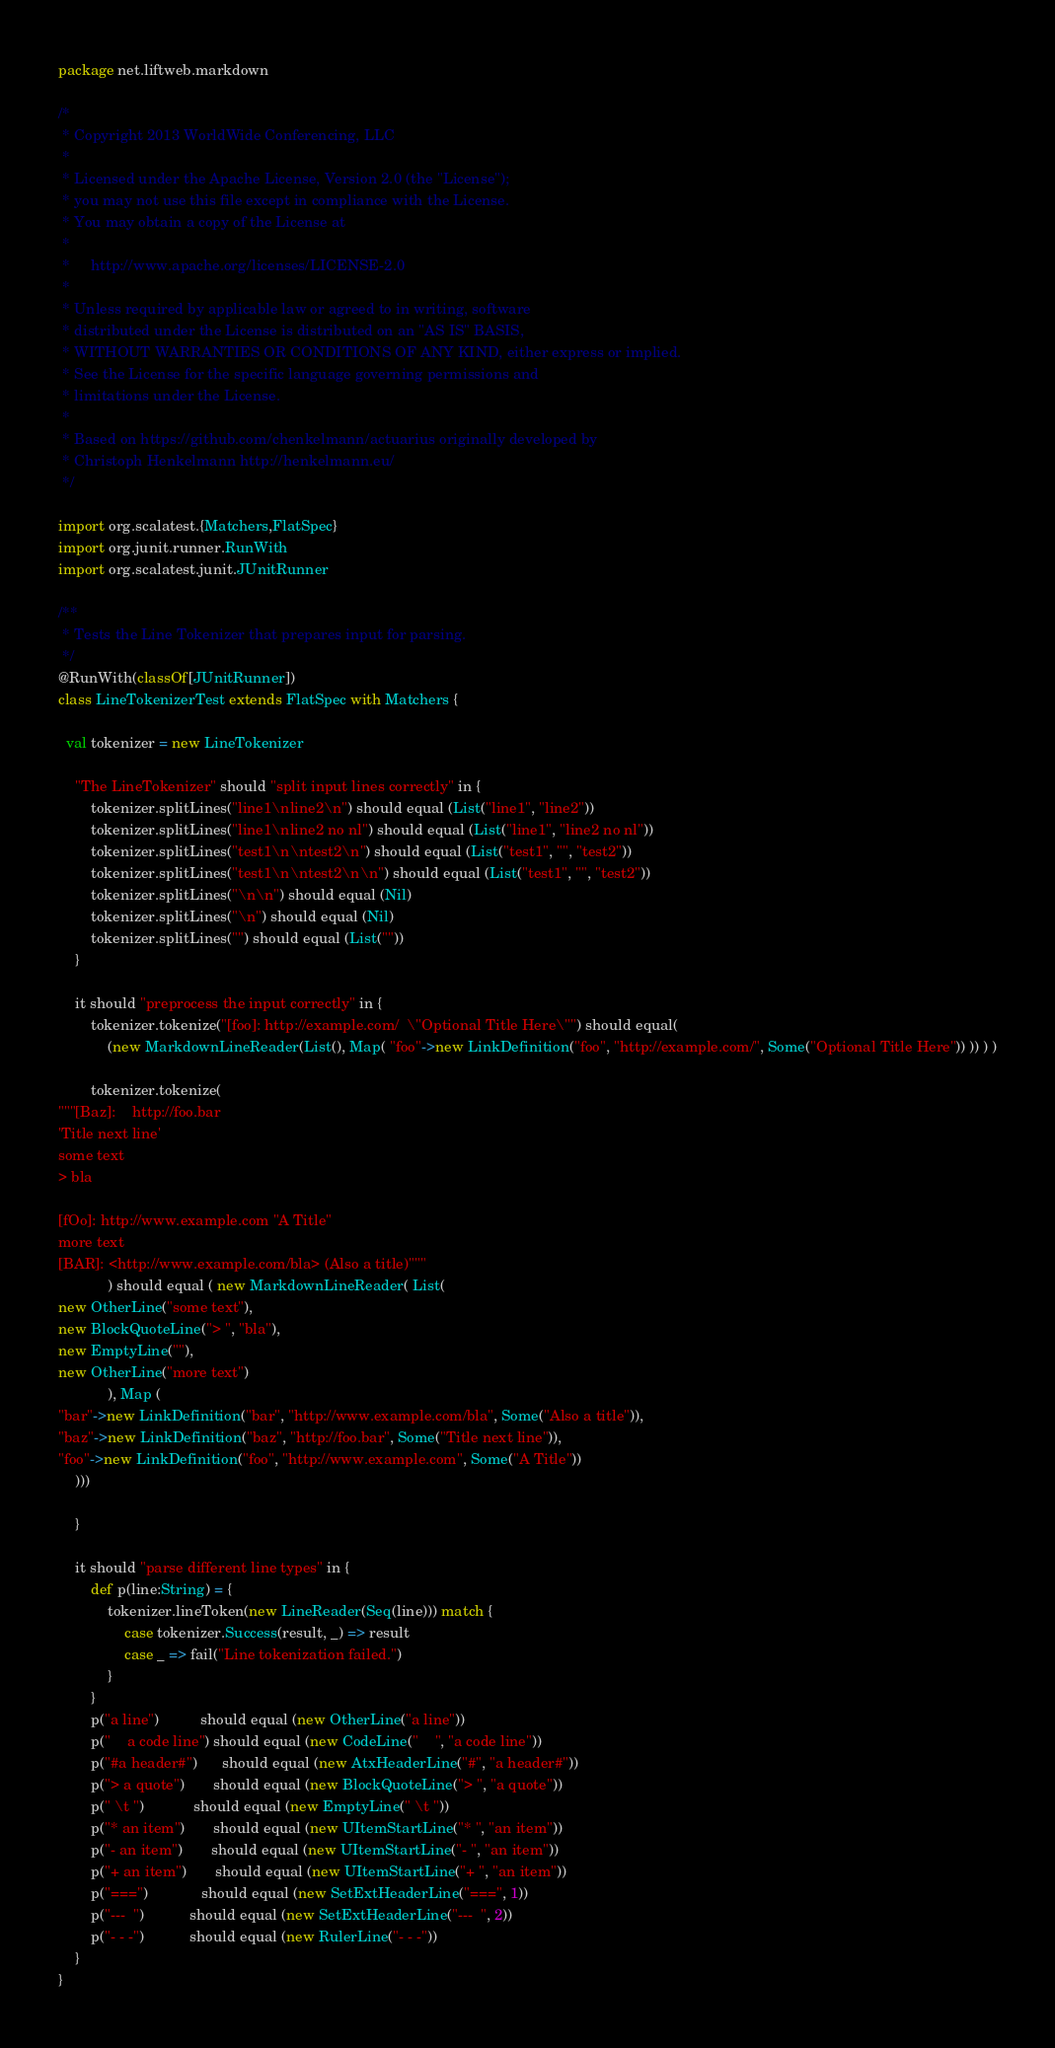<code> <loc_0><loc_0><loc_500><loc_500><_Scala_>package net.liftweb.markdown

/*
 * Copyright 2013 WorldWide Conferencing, LLC
 *
 * Licensed under the Apache License, Version 2.0 (the "License");
 * you may not use this file except in compliance with the License.
 * You may obtain a copy of the License at
 *
 *     http://www.apache.org/licenses/LICENSE-2.0
 *
 * Unless required by applicable law or agreed to in writing, software
 * distributed under the License is distributed on an "AS IS" BASIS,
 * WITHOUT WARRANTIES OR CONDITIONS OF ANY KIND, either express or implied.
 * See the License for the specific language governing permissions and
 * limitations under the License.
 *
 * Based on https://github.com/chenkelmann/actuarius originally developed by
 * Christoph Henkelmann http://henkelmann.eu/
 */

import org.scalatest.{Matchers,FlatSpec}
import org.junit.runner.RunWith
import org.scalatest.junit.JUnitRunner

/**
 * Tests the Line Tokenizer that prepares input for parsing.
 */
@RunWith(classOf[JUnitRunner])
class LineTokenizerTest extends FlatSpec with Matchers {

  val tokenizer = new LineTokenizer

    "The LineTokenizer" should "split input lines correctly" in {
        tokenizer.splitLines("line1\nline2\n") should equal (List("line1", "line2"))
        tokenizer.splitLines("line1\nline2 no nl") should equal (List("line1", "line2 no nl"))
        tokenizer.splitLines("test1\n\ntest2\n") should equal (List("test1", "", "test2"))
        tokenizer.splitLines("test1\n\ntest2\n\n") should equal (List("test1", "", "test2"))
        tokenizer.splitLines("\n\n") should equal (Nil)
        tokenizer.splitLines("\n") should equal (Nil)
        tokenizer.splitLines("") should equal (List(""))
    }

    it should "preprocess the input correctly" in {
        tokenizer.tokenize("[foo]: http://example.com/  \"Optional Title Here\"") should equal(
            (new MarkdownLineReader(List(), Map( "foo"->new LinkDefinition("foo", "http://example.com/", Some("Optional Title Here")) )) ) )

        tokenizer.tokenize(
"""[Baz]:    http://foo.bar
'Title next line'
some text
> bla

[fOo]: http://www.example.com "A Title"
more text
[BAR]: <http://www.example.com/bla> (Also a title)"""
            ) should equal ( new MarkdownLineReader( List(
new OtherLine("some text"),
new BlockQuoteLine("> ", "bla"),
new EmptyLine(""),
new OtherLine("more text")
            ), Map (
"bar"->new LinkDefinition("bar", "http://www.example.com/bla", Some("Also a title")),
"baz"->new LinkDefinition("baz", "http://foo.bar", Some("Title next line")),
"foo"->new LinkDefinition("foo", "http://www.example.com", Some("A Title"))
    )))

    }

    it should "parse different line types" in {
        def p(line:String) = {
            tokenizer.lineToken(new LineReader(Seq(line))) match {
                case tokenizer.Success(result, _) => result
                case _ => fail("Line tokenization failed.")
            }
        }
        p("a line")          should equal (new OtherLine("a line"))
        p("    a code line") should equal (new CodeLine("    ", "a code line"))
        p("#a header#")      should equal (new AtxHeaderLine("#", "a header#"))
        p("> a quote")       should equal (new BlockQuoteLine("> ", "a quote"))
        p(" \t ")            should equal (new EmptyLine(" \t "))
        p("* an item")       should equal (new UItemStartLine("* ", "an item"))
        p("- an item")       should equal (new UItemStartLine("- ", "an item"))
        p("+ an item")       should equal (new UItemStartLine("+ ", "an item"))
        p("===")             should equal (new SetExtHeaderLine("===", 1))
        p("---  ")           should equal (new SetExtHeaderLine("---  ", 2))
        p("- - -")           should equal (new RulerLine("- - -"))
    }
}
</code> 